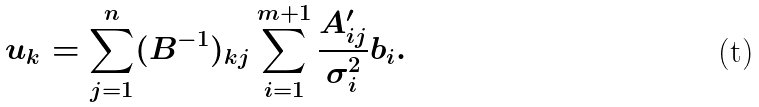Convert formula to latex. <formula><loc_0><loc_0><loc_500><loc_500>u _ { k } = \sum _ { j = 1 } ^ { n } ( B ^ { - 1 } ) _ { k j } \sum _ { i = 1 } ^ { m + 1 } \frac { A ^ { \prime } _ { i j } } { \sigma _ { i } ^ { 2 } } b _ { i } .</formula> 